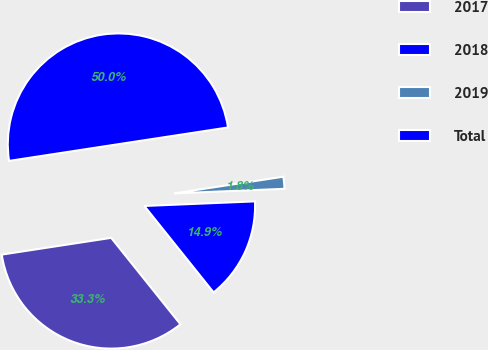Convert chart to OTSL. <chart><loc_0><loc_0><loc_500><loc_500><pie_chart><fcel>2017<fcel>2018<fcel>2019<fcel>Total<nl><fcel>33.33%<fcel>14.91%<fcel>1.75%<fcel>50.0%<nl></chart> 